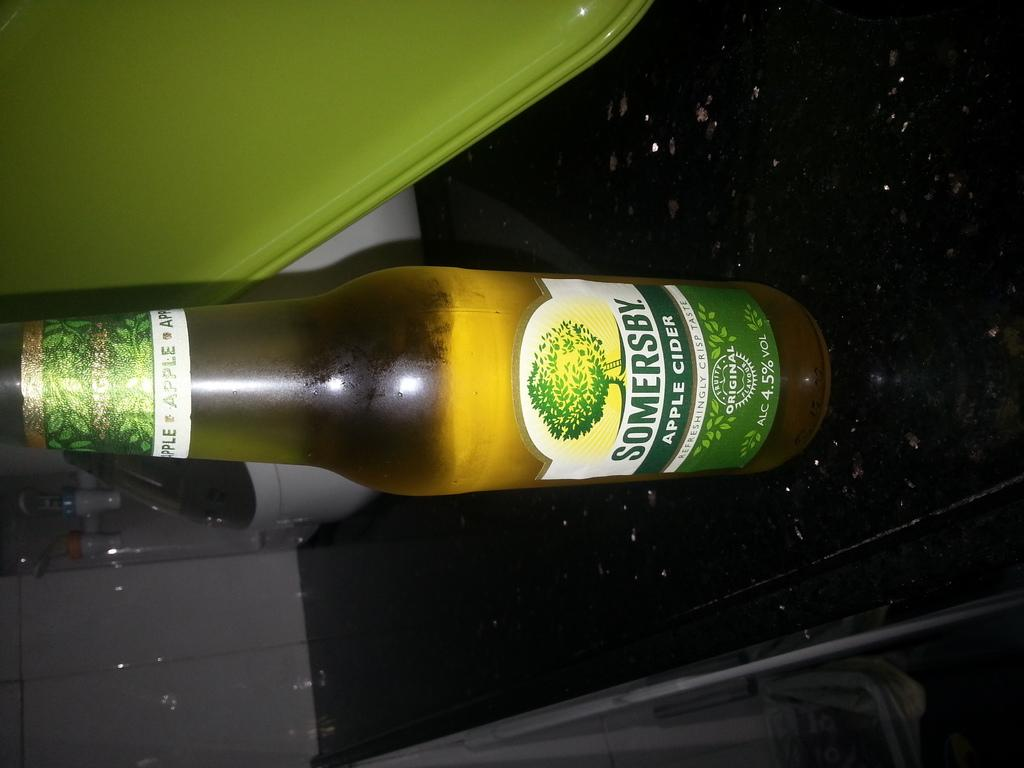<image>
Provide a brief description of the given image. A bottle of Somersby apple cider is on a black table. 